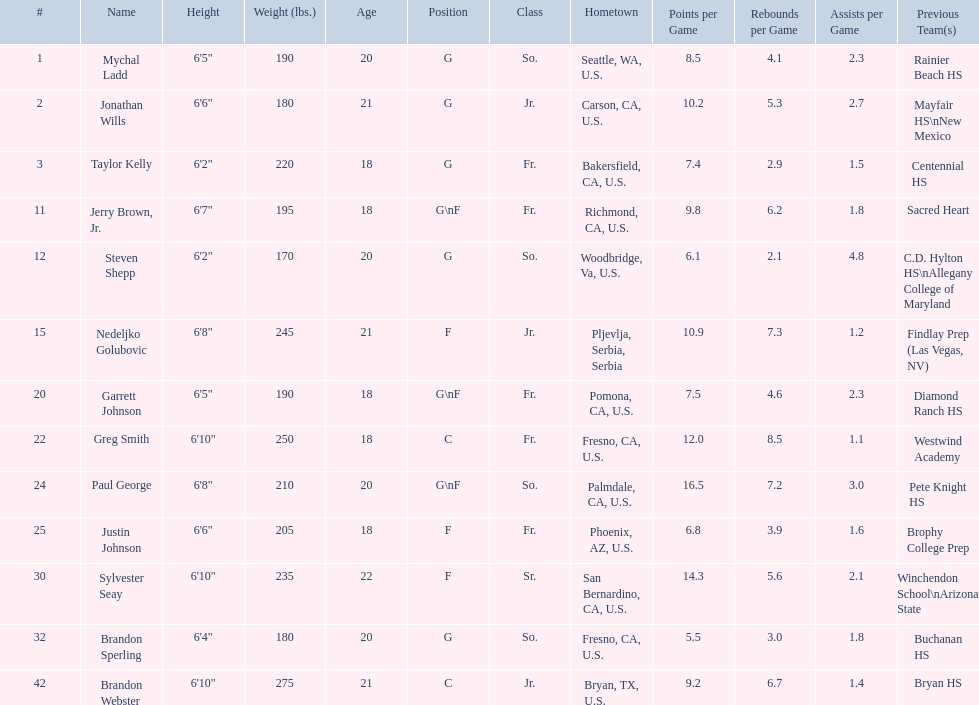What are the names of the basketball team players? Mychal Ladd, Jonathan Wills, Taylor Kelly, Jerry Brown, Jr., Steven Shepp, Nedeljko Golubovic, Garrett Johnson, Greg Smith, Paul George, Justin Johnson, Sylvester Seay, Brandon Sperling, Brandon Webster. Of these identify paul george and greg smith Greg Smith, Paul George. What are their corresponding heights? 6'10", 6'8". To who does the larger height correspond to? Greg Smith. 